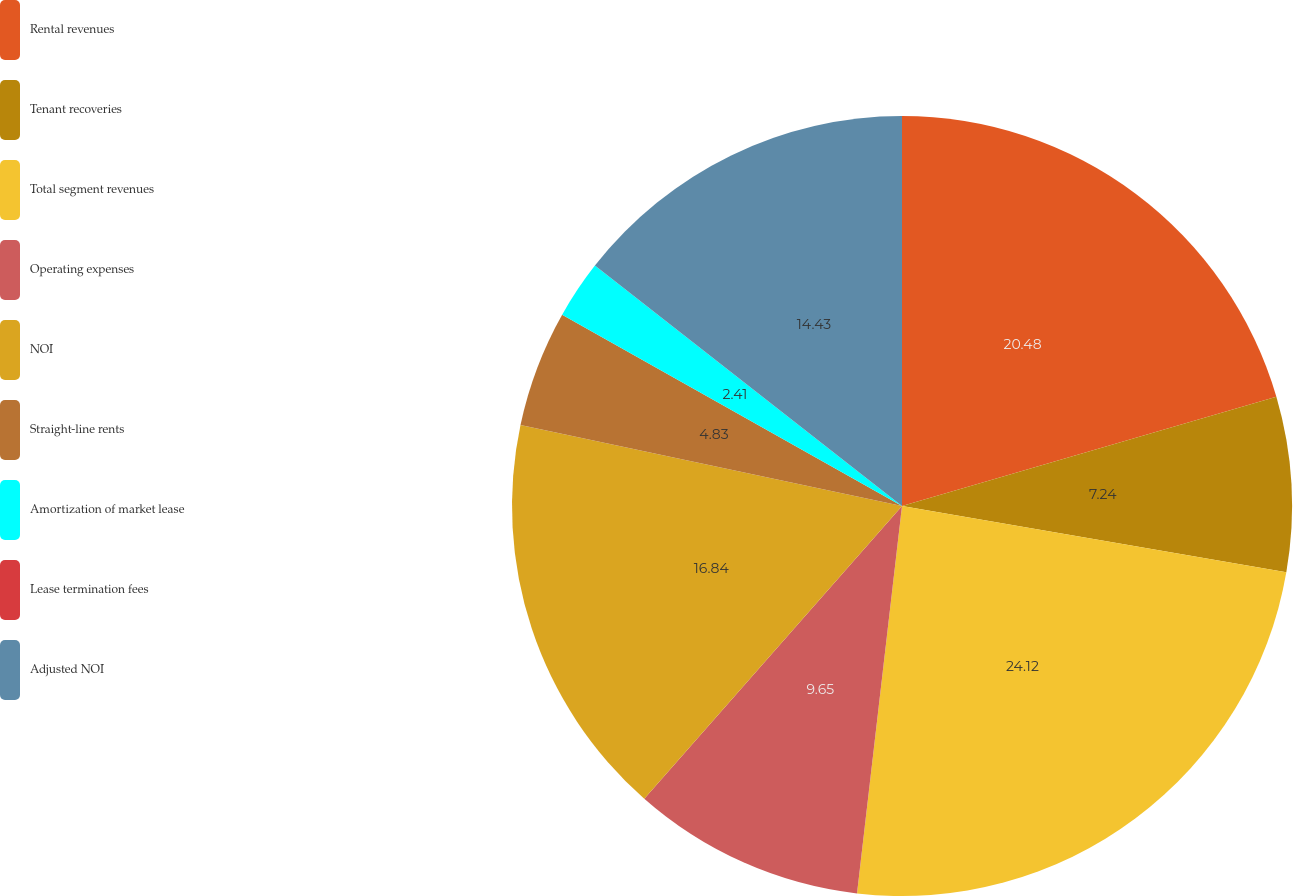<chart> <loc_0><loc_0><loc_500><loc_500><pie_chart><fcel>Rental revenues<fcel>Tenant recoveries<fcel>Total segment revenues<fcel>Operating expenses<fcel>NOI<fcel>Straight-line rents<fcel>Amortization of market lease<fcel>Lease termination fees<fcel>Adjusted NOI<nl><fcel>20.48%<fcel>7.24%<fcel>24.12%<fcel>9.65%<fcel>16.84%<fcel>4.83%<fcel>2.41%<fcel>0.0%<fcel>14.43%<nl></chart> 